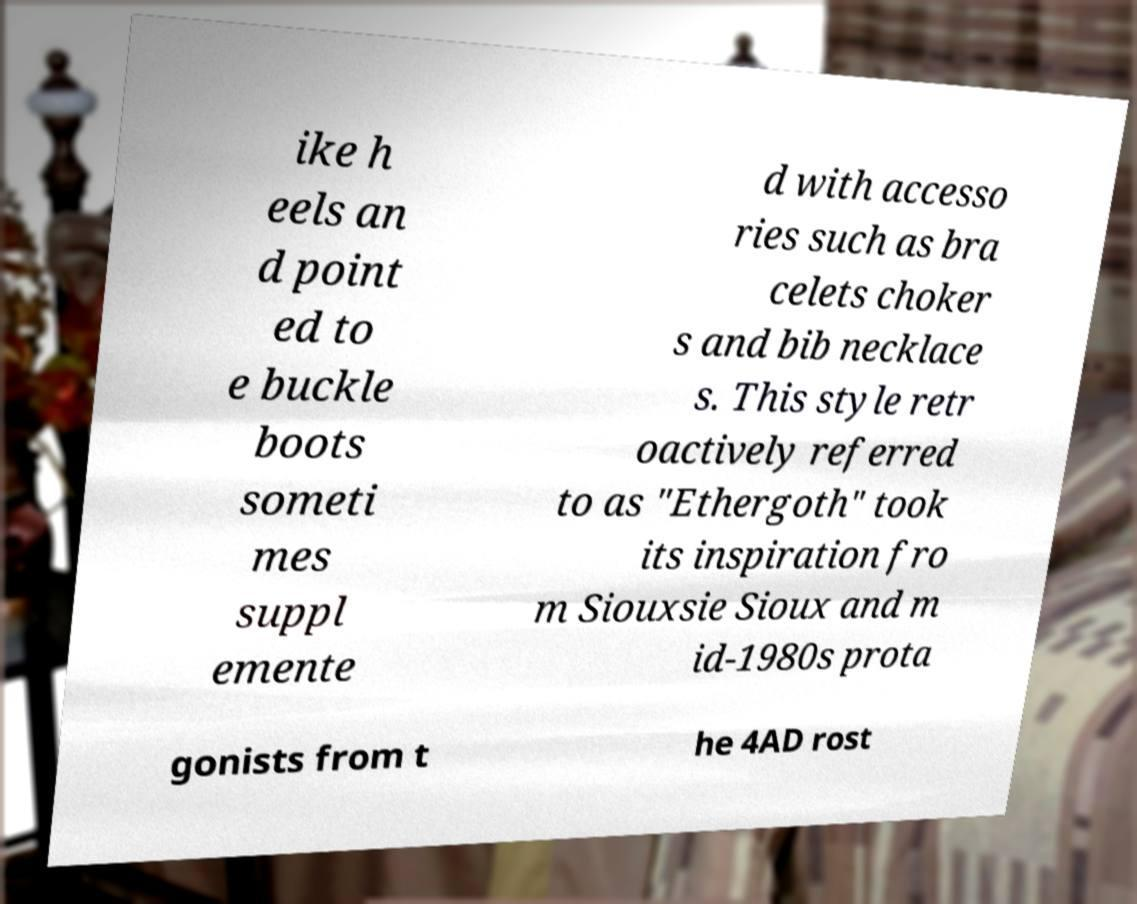For documentation purposes, I need the text within this image transcribed. Could you provide that? ike h eels an d point ed to e buckle boots someti mes suppl emente d with accesso ries such as bra celets choker s and bib necklace s. This style retr oactively referred to as "Ethergoth" took its inspiration fro m Siouxsie Sioux and m id-1980s prota gonists from t he 4AD rost 